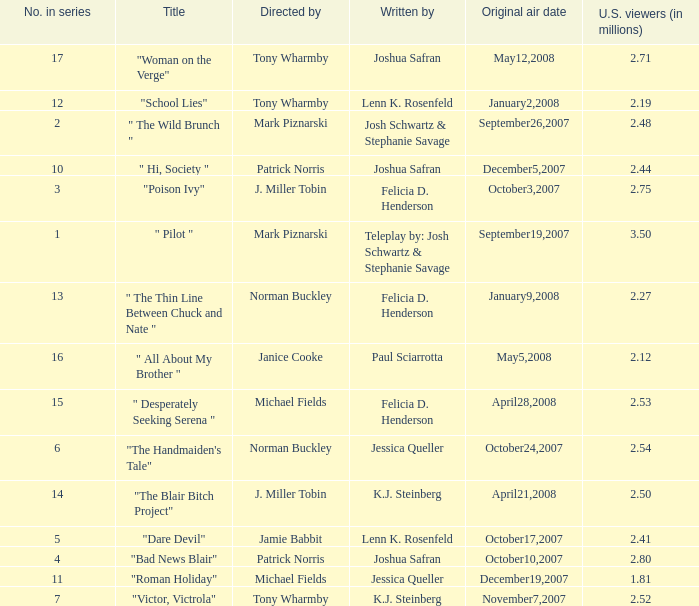How many u.s. viewers  (in millions) have "dare devil" as the title? 2.41. 